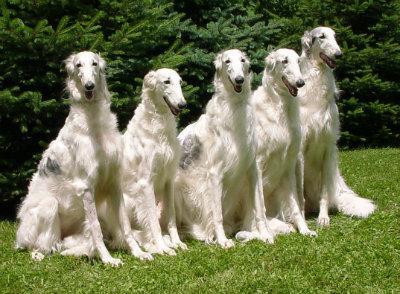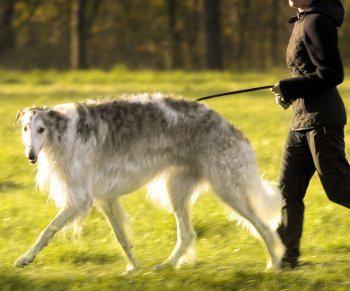The first image is the image on the left, the second image is the image on the right. Analyze the images presented: Is the assertion "There is more than one dog in the image on the left." valid? Answer yes or no. Yes. 